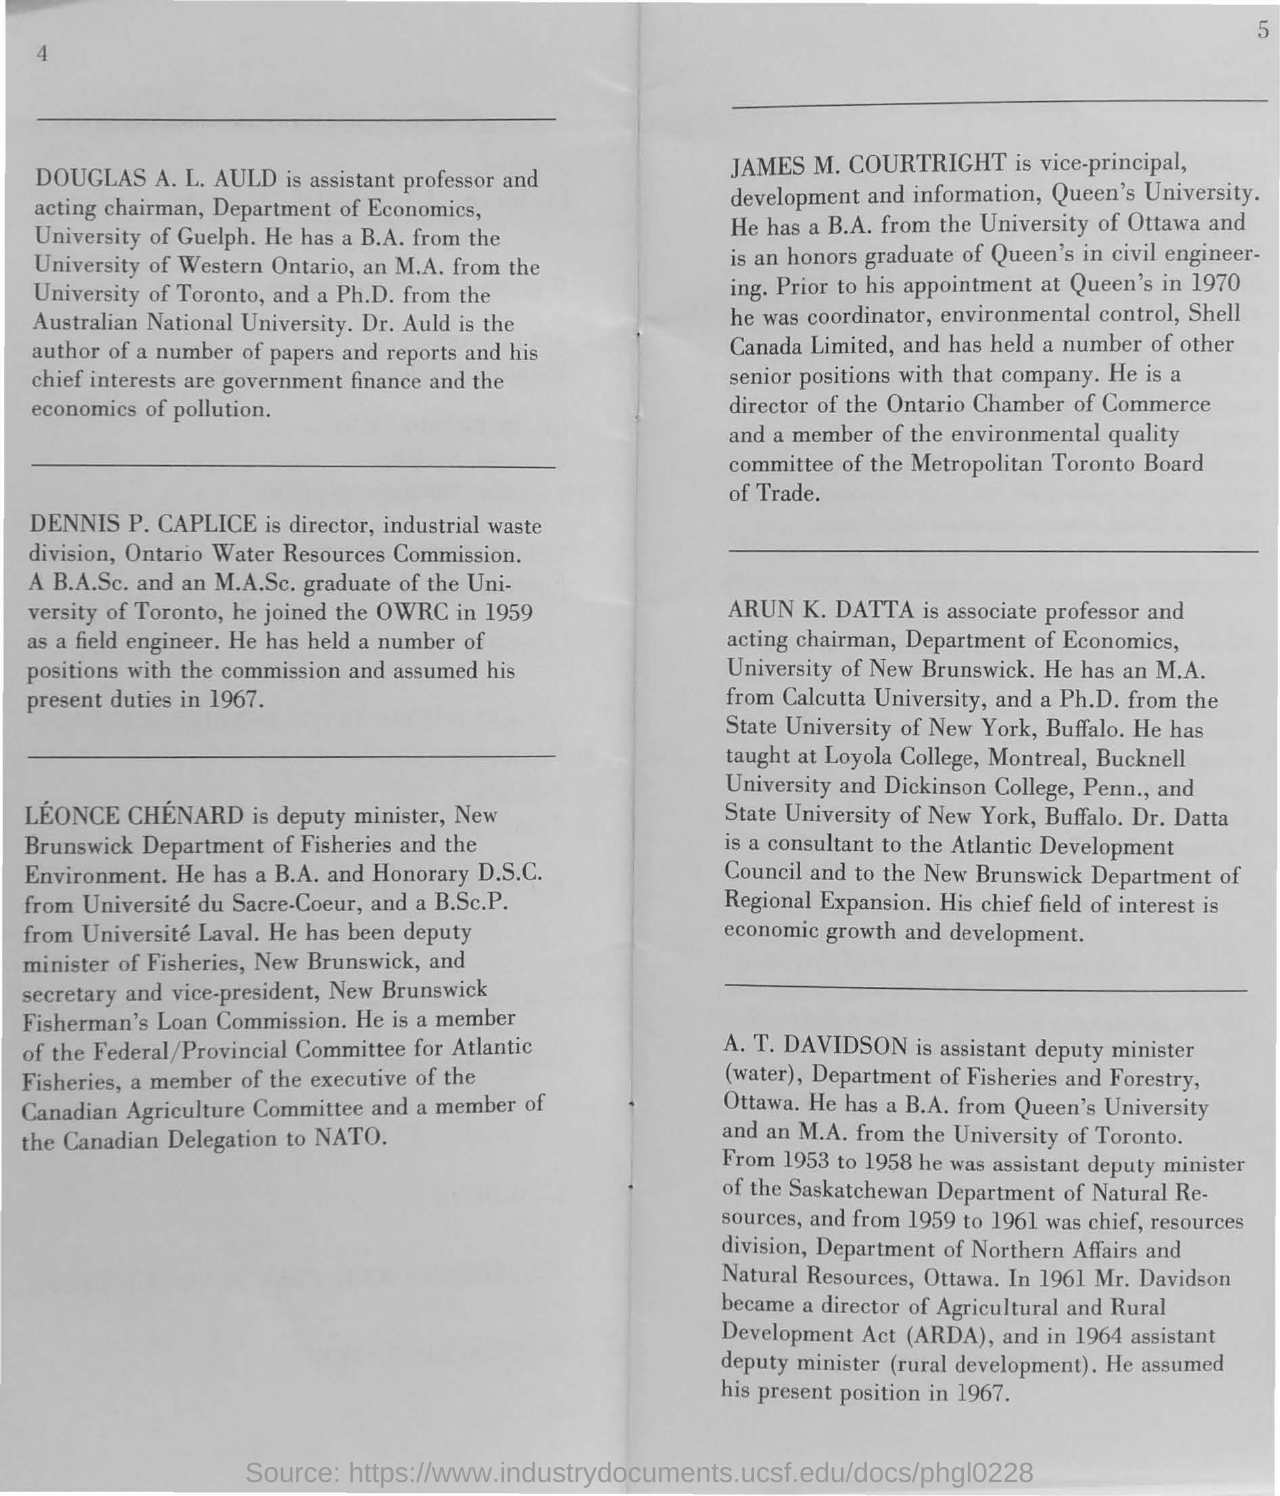Indicate a few pertinent items in this graphic. The Agricultural and Rural Development Act, commonly referred to as ARDA, is a legislative act that aims to promote agricultural and rural development in various regions of the country. Douglas A. L. Auhl is the assistant professor and acting chairman of the University of Guelph. 